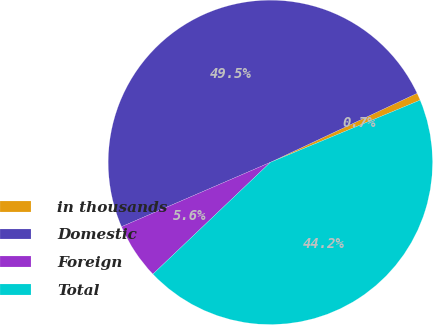Convert chart. <chart><loc_0><loc_0><loc_500><loc_500><pie_chart><fcel>in thousands<fcel>Domestic<fcel>Foreign<fcel>Total<nl><fcel>0.74%<fcel>49.49%<fcel>5.61%<fcel>44.16%<nl></chart> 